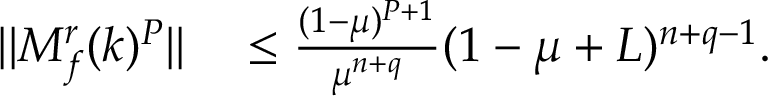Convert formula to latex. <formula><loc_0><loc_0><loc_500><loc_500>\begin{array} { r l } { | | M _ { f } ^ { r } ( k ) ^ { P } | | } & \leq \frac { ( 1 - \mu ) ^ { P + 1 } } { \mu ^ { n + q } } ( 1 - \mu + L ) ^ { n + q - 1 } . } \end{array}</formula> 